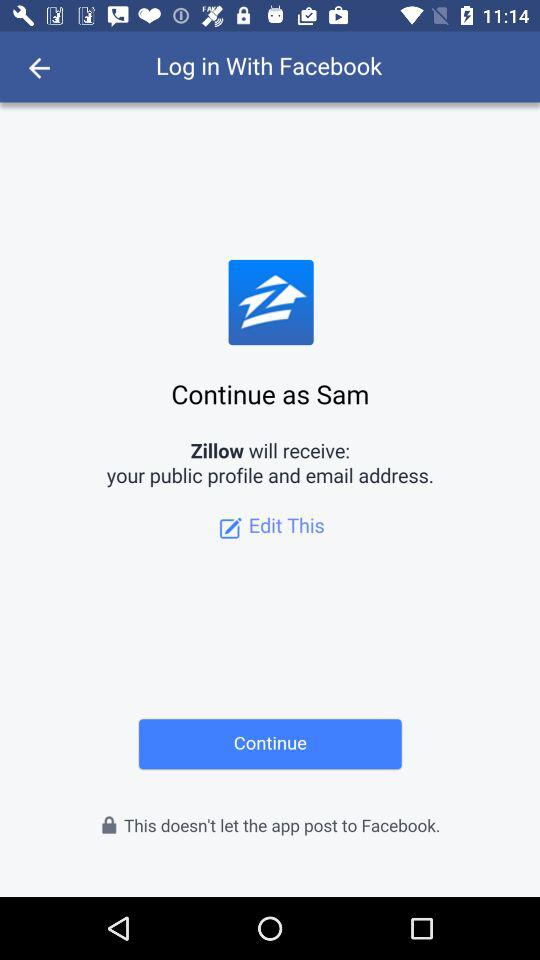Can we edit personal details?
When the provided information is insufficient, respond with <no answer>. <no answer> 